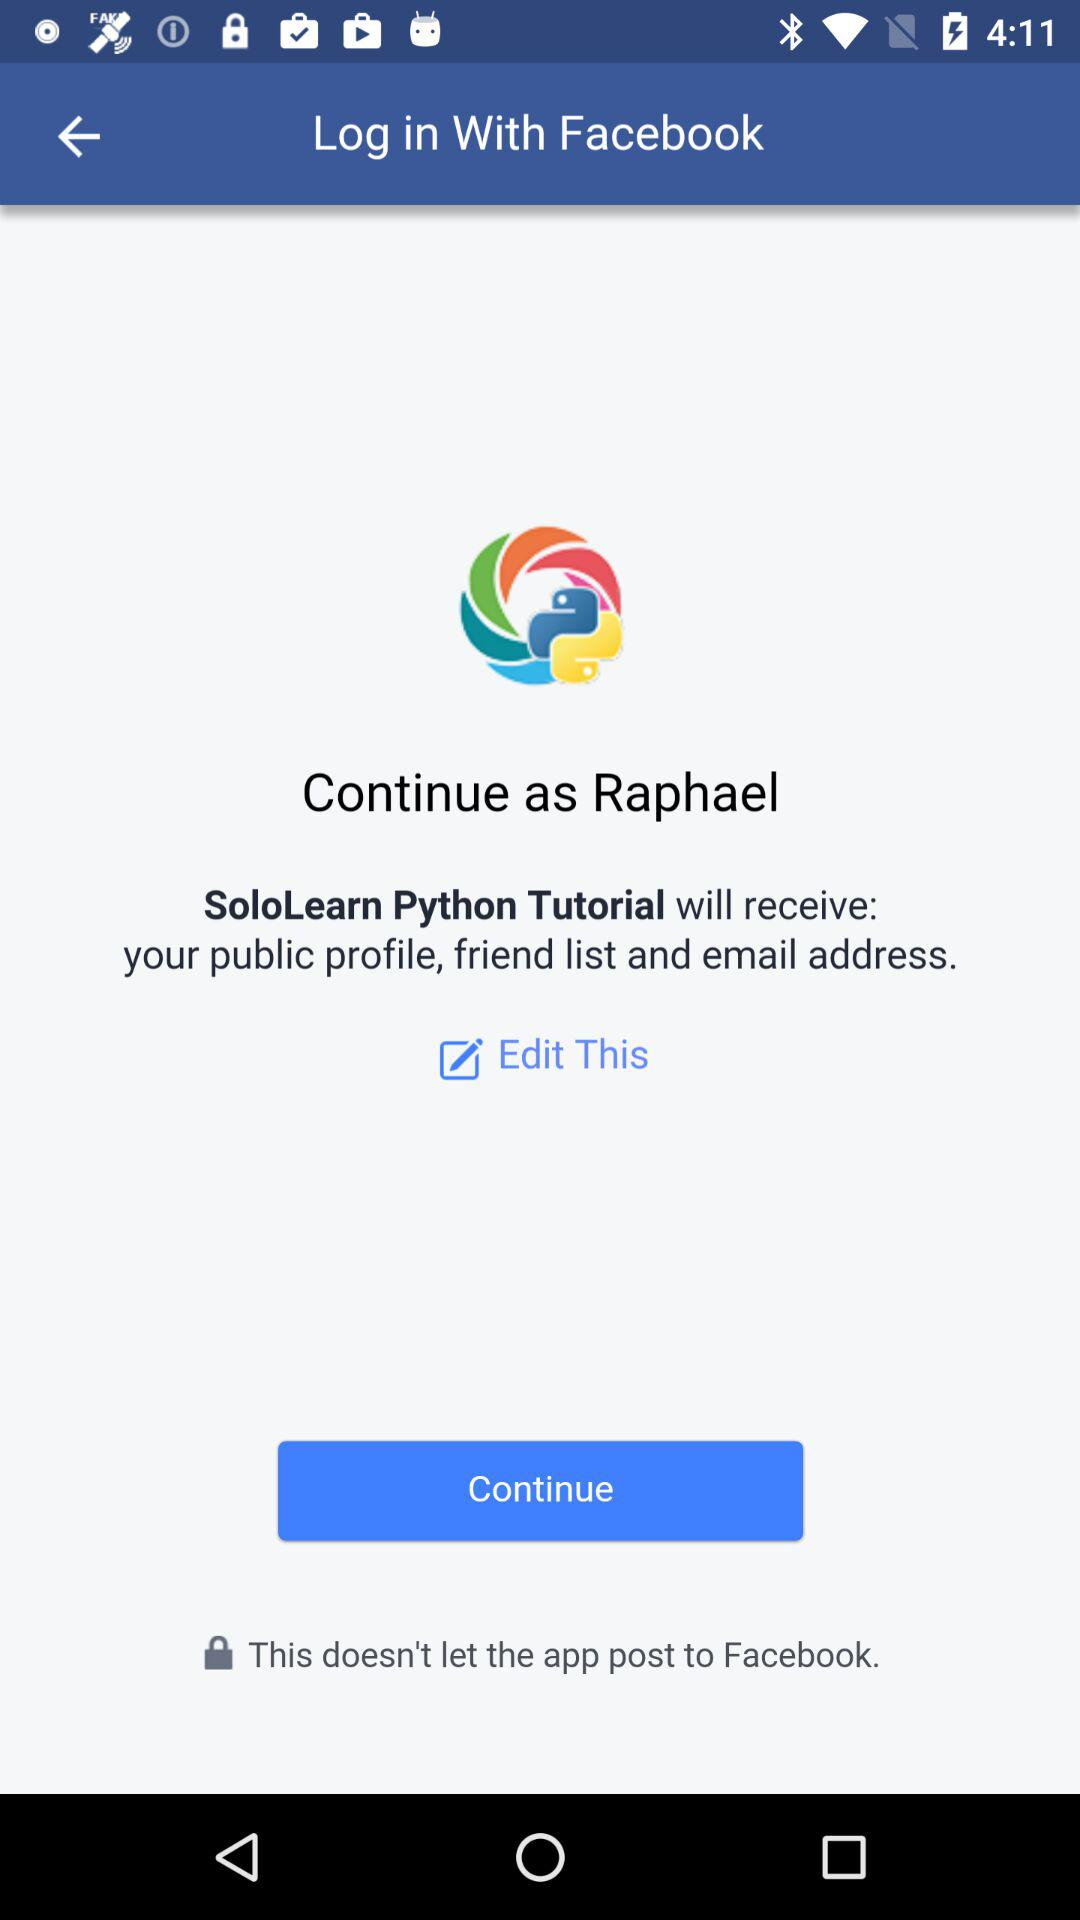What is the login name? The login name is Raphael. 